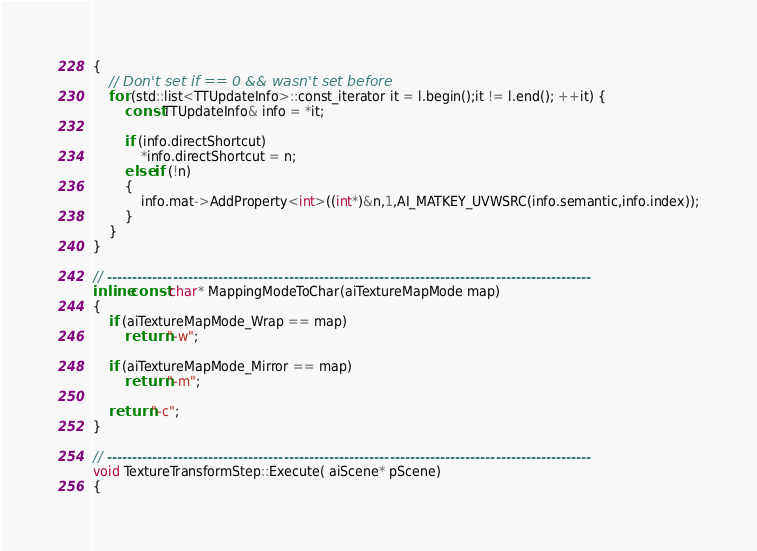Convert code to text. <code><loc_0><loc_0><loc_500><loc_500><_C++_>{
	// Don't set if == 0 && wasn't set before
	for (std::list<TTUpdateInfo>::const_iterator it = l.begin();it != l.end(); ++it) {
		const TTUpdateInfo& info = *it;

		if (info.directShortcut)
			*info.directShortcut = n;
		else if (!n)
		{
			info.mat->AddProperty<int>((int*)&n,1,AI_MATKEY_UVWSRC(info.semantic,info.index));
		}
	}
}

// ------------------------------------------------------------------------------------------------
inline const char* MappingModeToChar(aiTextureMapMode map)
{
	if (aiTextureMapMode_Wrap == map)
		return "-w";

	if (aiTextureMapMode_Mirror == map)
		return "-m";
	
	return "-c";
}

// ------------------------------------------------------------------------------------------------
void TextureTransformStep::Execute( aiScene* pScene) 
{</code> 